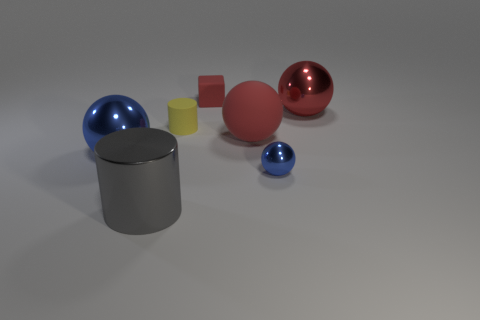Is the number of metallic things that are left of the large gray metal thing less than the number of large blue metallic spheres that are behind the red metallic ball?
Ensure brevity in your answer.  No. There is a thing that is the same color as the small ball; what is it made of?
Give a very brief answer. Metal. What is the color of the shiny object that is right of the tiny blue thing?
Provide a succinct answer. Red. Do the small block and the large matte thing have the same color?
Offer a terse response. Yes. What number of large gray things are left of the cylinder behind the thing that is in front of the small blue metal sphere?
Give a very brief answer. 1. What is the size of the red cube?
Your answer should be compact. Small. What is the material of the blue sphere that is the same size as the gray shiny thing?
Give a very brief answer. Metal. How many metallic cylinders are on the left side of the big gray thing?
Your answer should be compact. 0. Are the large gray object left of the tiny shiny object and the large red sphere right of the large red matte sphere made of the same material?
Offer a terse response. Yes. There is a small object that is to the left of the small thing behind the large ball that is behind the small matte cylinder; what is its shape?
Give a very brief answer. Cylinder. 